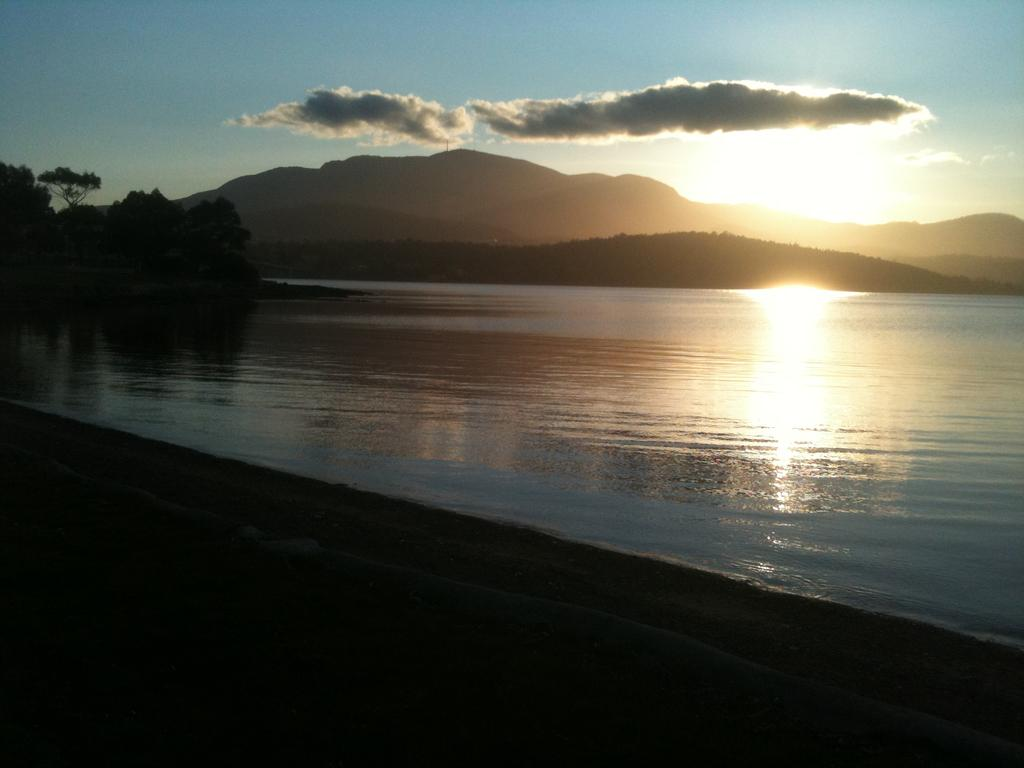What is the primary element visible in the image? There is water in the image. What can be seen in the background of the image? There are trees and hills in the background of the image. What is visible in the sky in the image? The sky is visible in the background of the image, and there are clouds and the sun visible. What grade does the pot receive in the image? There is no pot present in the image, and therefore no grade can be assigned. 